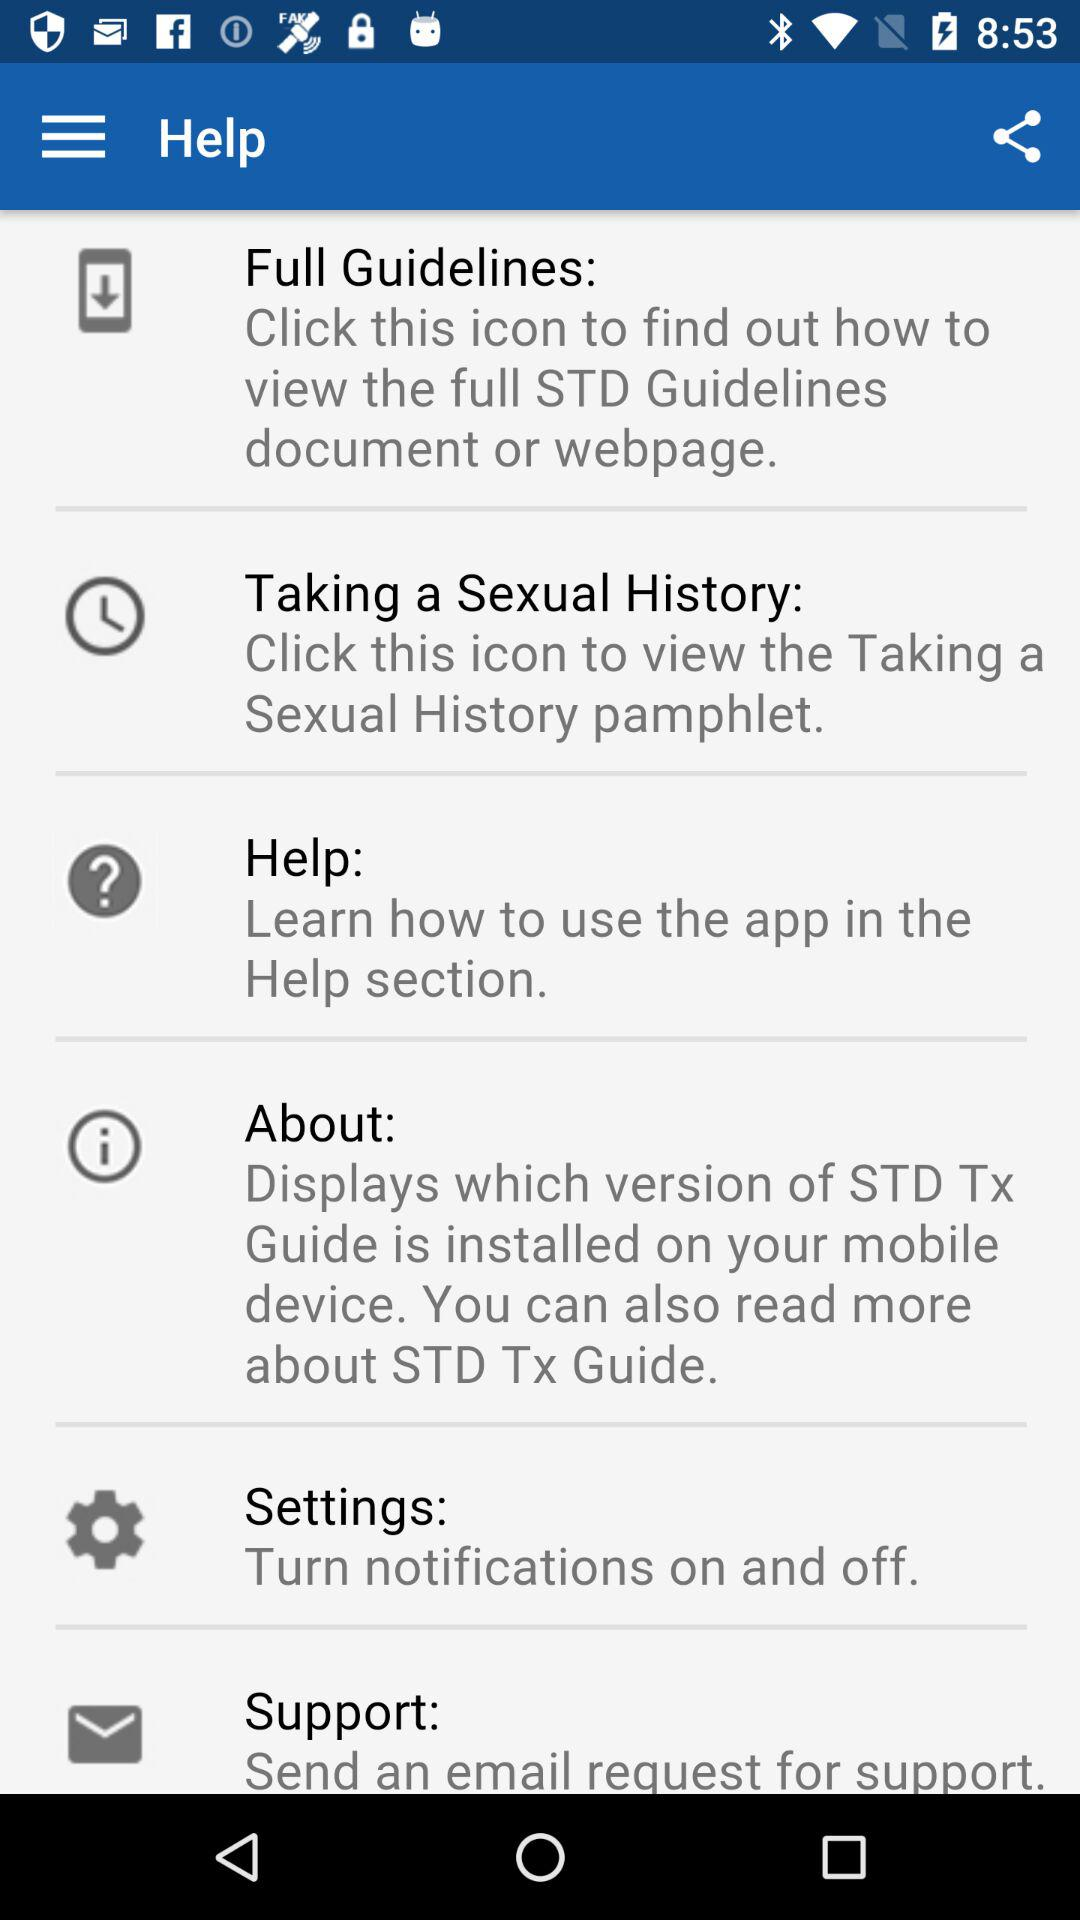What is the description of the "Settings"? The description is "Turn notifications on and off". 